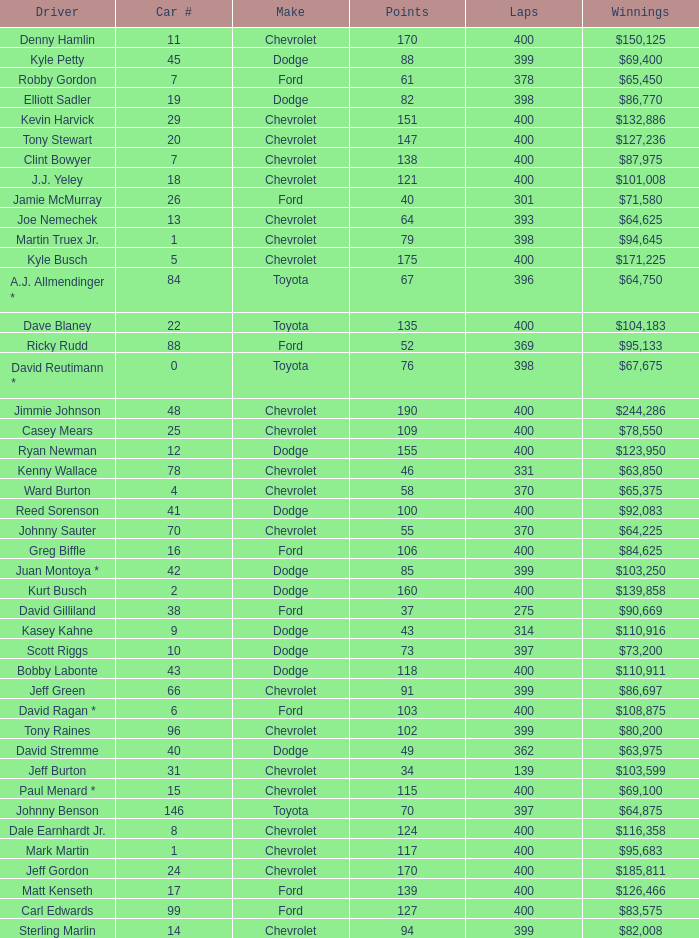What were the winnings for the Chevrolet with a number larger than 29 and scored 102 points? $80,200. 